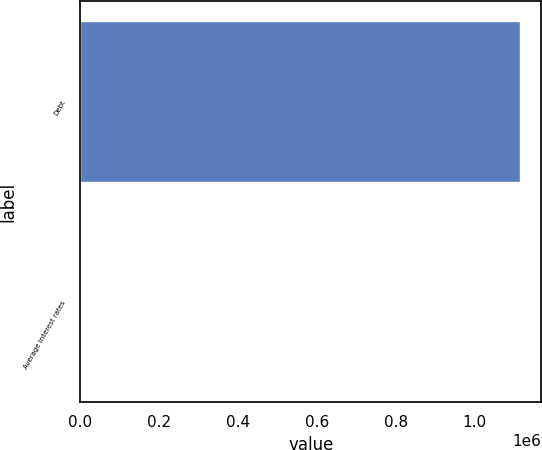Convert chart. <chart><loc_0><loc_0><loc_500><loc_500><bar_chart><fcel>Debt<fcel>Average interest rates<nl><fcel>1.11313e+06<fcel>4.8<nl></chart> 